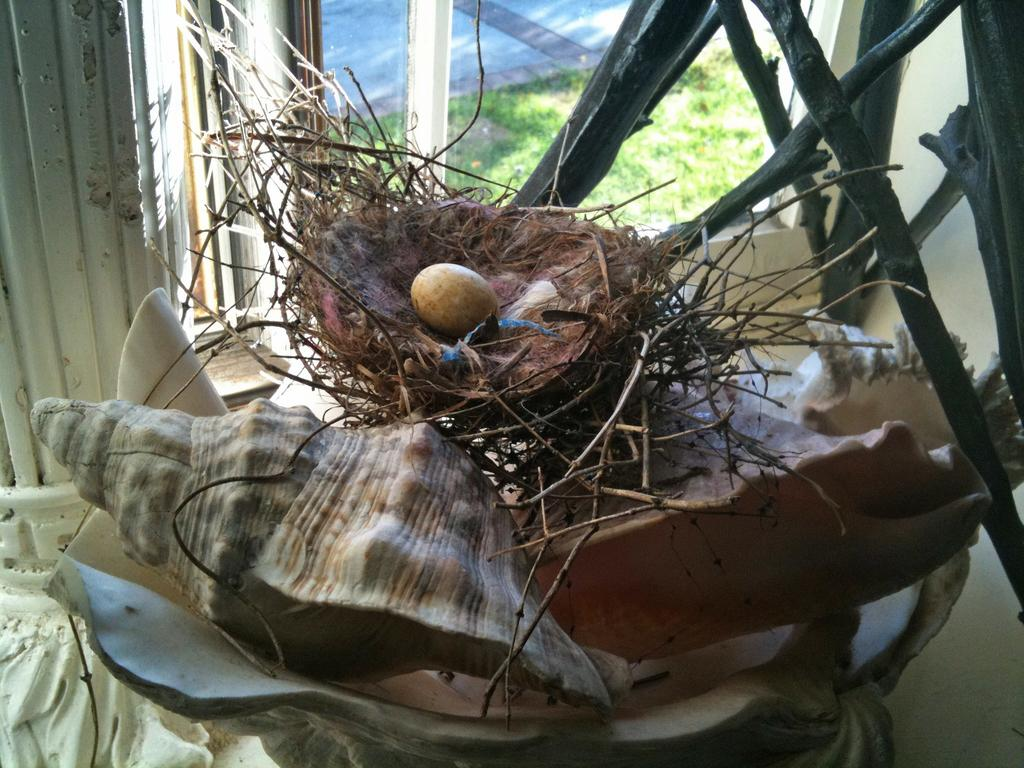What is the main object in the image? There is a shell in the image. What can be seen near the shell? There is an egg in a nest in the image. What is located on the right side of the image? There are sticks on the right side of the image. What type of vegetation is visible in the background of the image? There is grass visible in the background of the image. What architectural feature can be seen in the background of the image? There is a window in the background of the image. What type of society is depicted in the image? There is no depiction of a society in the image; it features a shell, an egg in a nest, sticks, grass, and a window. What is the yoke used for in the image? There is no yoke present in the image. 